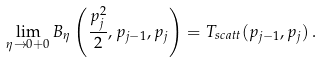Convert formula to latex. <formula><loc_0><loc_0><loc_500><loc_500>\lim _ { \eta \to 0 + 0 } B _ { \eta } \left ( \frac { p _ { j } ^ { 2 } } { 2 } , p _ { j - 1 } , p _ { j } \right ) = T _ { s c a t t } ( p _ { j - 1 } , p _ { j } ) \, .</formula> 